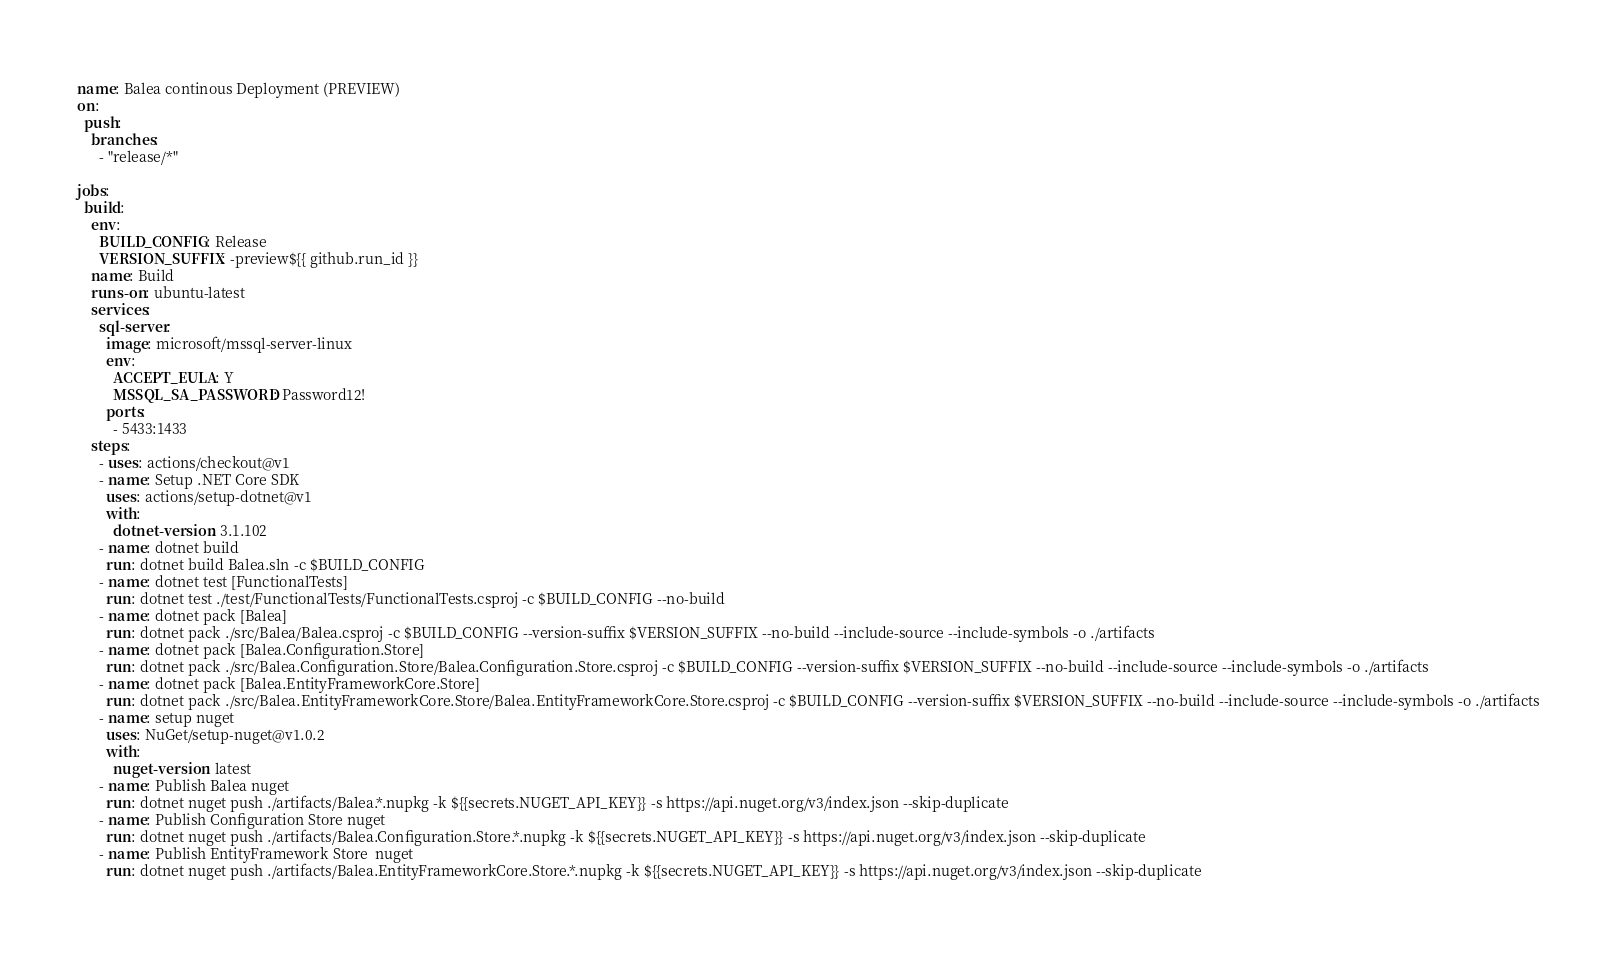Convert code to text. <code><loc_0><loc_0><loc_500><loc_500><_YAML_>name: Balea continous Deployment (PREVIEW)
on:
  push:
    branches:
      - "release/*"

jobs:
  build:
    env:
      BUILD_CONFIG: Release
      VERSION_SUFFIX: -preview${{ github.run_id }}
    name: Build
    runs-on: ubuntu-latest
    services:
      sql-server:
        image: microsoft/mssql-server-linux
        env:
          ACCEPT_EULA: Y
          MSSQL_SA_PASSWORD: Password12!
        ports:
          - 5433:1433
    steps:
      - uses: actions/checkout@v1
      - name: Setup .NET Core SDK
        uses: actions/setup-dotnet@v1
        with:
          dotnet-version: 3.1.102
      - name: dotnet build
        run: dotnet build Balea.sln -c $BUILD_CONFIG
      - name: dotnet test [FunctionalTests]
        run: dotnet test ./test/FunctionalTests/FunctionalTests.csproj -c $BUILD_CONFIG --no-build
      - name: dotnet pack [Balea]
        run: dotnet pack ./src/Balea/Balea.csproj -c $BUILD_CONFIG --version-suffix $VERSION_SUFFIX --no-build --include-source --include-symbols -o ./artifacts
      - name: dotnet pack [Balea.Configuration.Store]
        run: dotnet pack ./src/Balea.Configuration.Store/Balea.Configuration.Store.csproj -c $BUILD_CONFIG --version-suffix $VERSION_SUFFIX --no-build --include-source --include-symbols -o ./artifacts
      - name: dotnet pack [Balea.EntityFrameworkCore.Store]
        run: dotnet pack ./src/Balea.EntityFrameworkCore.Store/Balea.EntityFrameworkCore.Store.csproj -c $BUILD_CONFIG --version-suffix $VERSION_SUFFIX --no-build --include-source --include-symbols -o ./artifacts
      - name: setup nuget
        uses: NuGet/setup-nuget@v1.0.2
        with:
          nuget-version: latest
      - name: Publish Balea nuget
        run: dotnet nuget push ./artifacts/Balea.*.nupkg -k ${{secrets.NUGET_API_KEY}} -s https://api.nuget.org/v3/index.json --skip-duplicate
      - name: Publish Configuration Store nuget
        run: dotnet nuget push ./artifacts/Balea.Configuration.Store.*.nupkg -k ${{secrets.NUGET_API_KEY}} -s https://api.nuget.org/v3/index.json --skip-duplicate
      - name: Publish EntityFramework Store  nuget
        run: dotnet nuget push ./artifacts/Balea.EntityFrameworkCore.Store.*.nupkg -k ${{secrets.NUGET_API_KEY}} -s https://api.nuget.org/v3/index.json --skip-duplicate
</code> 